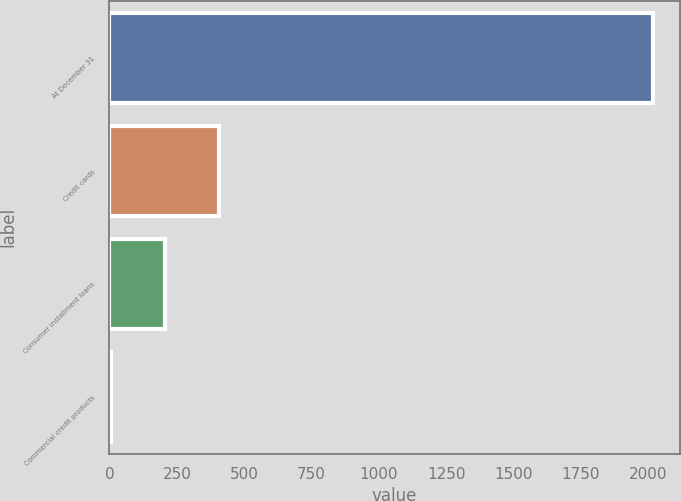Convert chart to OTSL. <chart><loc_0><loc_0><loc_500><loc_500><bar_chart><fcel>At December 31<fcel>Credit cards<fcel>Consumer installment loans<fcel>Commercial credit products<nl><fcel>2017<fcel>407.4<fcel>206.2<fcel>5<nl></chart> 